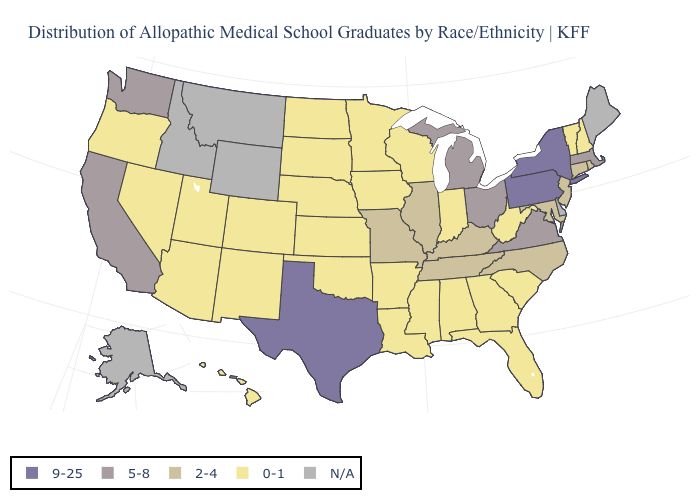What is the lowest value in the South?
Write a very short answer. 0-1. Which states hav the highest value in the West?
Short answer required. California, Washington. What is the value of Indiana?
Give a very brief answer. 0-1. What is the highest value in the USA?
Be succinct. 9-25. Name the states that have a value in the range 9-25?
Concise answer only. New York, Pennsylvania, Texas. What is the highest value in the MidWest ?
Keep it brief. 5-8. Name the states that have a value in the range 5-8?
Quick response, please. California, Massachusetts, Michigan, Ohio, Virginia, Washington. Name the states that have a value in the range 2-4?
Be succinct. Connecticut, Illinois, Kentucky, Maryland, Missouri, New Jersey, North Carolina, Rhode Island, Tennessee. What is the lowest value in states that border Maryland?
Concise answer only. 0-1. Name the states that have a value in the range 9-25?
Write a very short answer. New York, Pennsylvania, Texas. Name the states that have a value in the range 2-4?
Write a very short answer. Connecticut, Illinois, Kentucky, Maryland, Missouri, New Jersey, North Carolina, Rhode Island, Tennessee. Name the states that have a value in the range 5-8?
Concise answer only. California, Massachusetts, Michigan, Ohio, Virginia, Washington. Which states have the highest value in the USA?
Short answer required. New York, Pennsylvania, Texas. What is the value of Colorado?
Keep it brief. 0-1. 